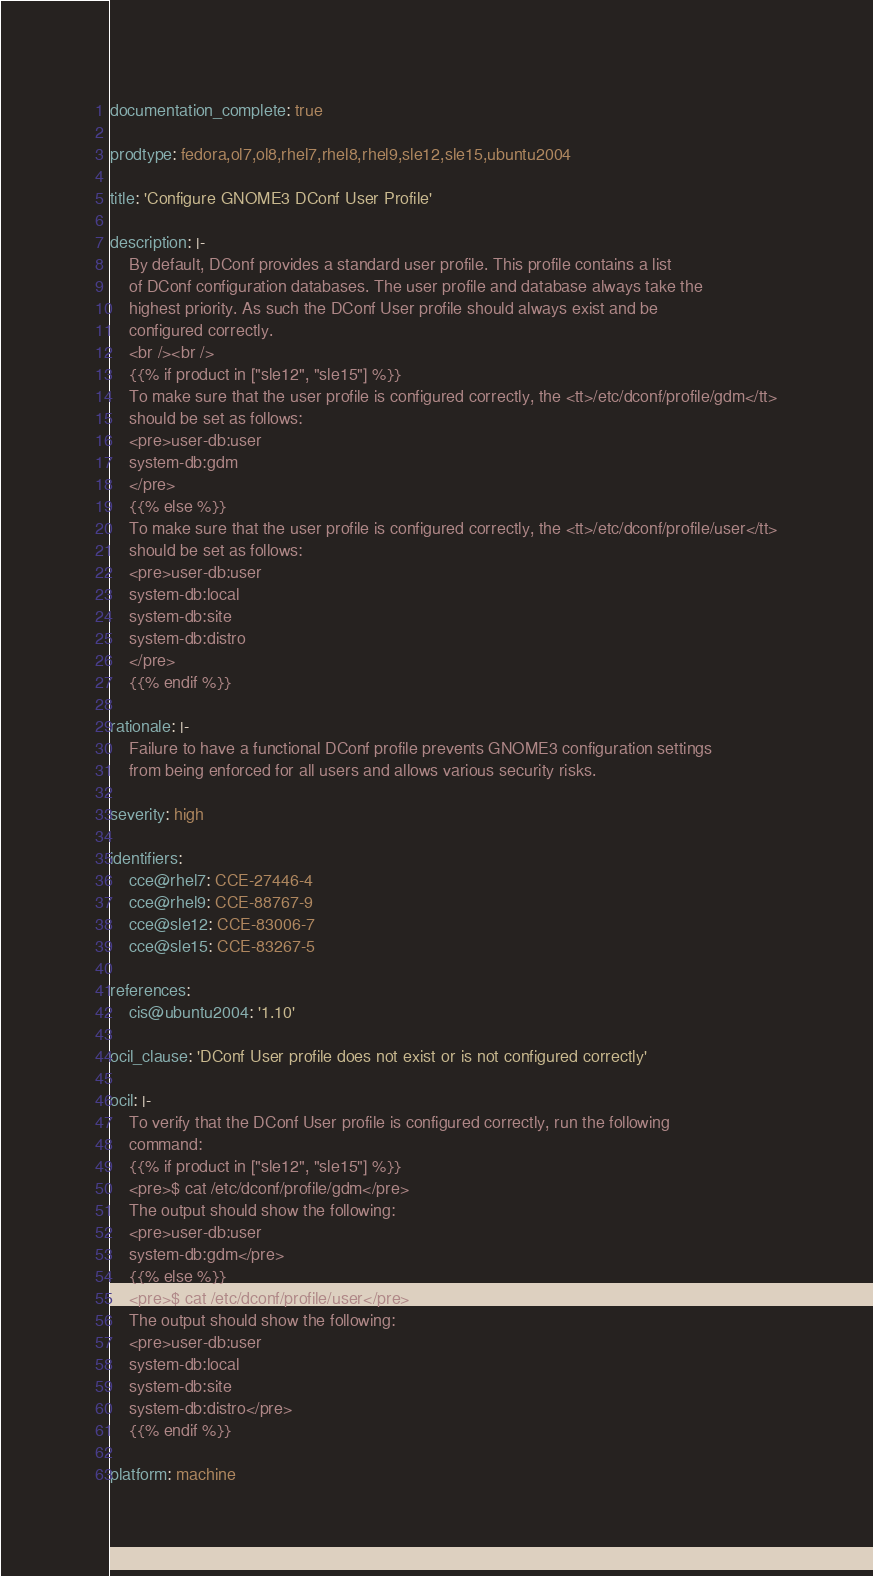Convert code to text. <code><loc_0><loc_0><loc_500><loc_500><_YAML_>documentation_complete: true

prodtype: fedora,ol7,ol8,rhel7,rhel8,rhel9,sle12,sle15,ubuntu2004

title: 'Configure GNOME3 DConf User Profile'

description: |-
    By default, DConf provides a standard user profile. This profile contains a list
    of DConf configuration databases. The user profile and database always take the
    highest priority. As such the DConf User profile should always exist and be
    configured correctly.
    <br /><br />
    {{% if product in ["sle12", "sle15"] %}}
    To make sure that the user profile is configured correctly, the <tt>/etc/dconf/profile/gdm</tt>
    should be set as follows:
    <pre>user-db:user
    system-db:gdm
    </pre>
    {{% else %}}
    To make sure that the user profile is configured correctly, the <tt>/etc/dconf/profile/user</tt>
    should be set as follows:
    <pre>user-db:user
    system-db:local
    system-db:site
    system-db:distro
    </pre>
    {{% endif %}}

rationale: |-
    Failure to have a functional DConf profile prevents GNOME3 configuration settings
    from being enforced for all users and allows various security risks.

severity: high

identifiers:
    cce@rhel7: CCE-27446-4
    cce@rhel9: CCE-88767-9
    cce@sle12: CCE-83006-7
    cce@sle15: CCE-83267-5

references:
    cis@ubuntu2004: '1.10'

ocil_clause: 'DConf User profile does not exist or is not configured correctly'

ocil: |-
    To verify that the DConf User profile is configured correctly, run the following
    command:
    {{% if product in ["sle12", "sle15"] %}}
    <pre>$ cat /etc/dconf/profile/gdm</pre>
    The output should show the following:
    <pre>user-db:user
    system-db:gdm</pre>
    {{% else %}}
    <pre>$ cat /etc/dconf/profile/user</pre>
    The output should show the following:
    <pre>user-db:user
    system-db:local
    system-db:site
    system-db:distro</pre>
    {{% endif %}}

platform: machine
</code> 